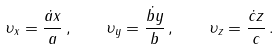Convert formula to latex. <formula><loc_0><loc_0><loc_500><loc_500>\upsilon _ { x } = \frac { \dot { a } x } { a } \, , \quad \upsilon _ { y } = \frac { \dot { b } y } { b } \, , \quad \upsilon _ { z } = \frac { \dot { c } z } { c } \, .</formula> 